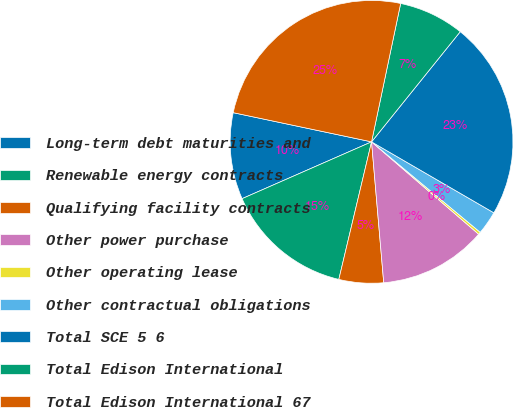Convert chart to OTSL. <chart><loc_0><loc_0><loc_500><loc_500><pie_chart><fcel>Long-term debt maturities and<fcel>Renewable energy contracts<fcel>Qualifying facility contracts<fcel>Other power purchase<fcel>Other operating lease<fcel>Other contractual obligations<fcel>Total SCE 5 6<fcel>Total Edison International<fcel>Total Edison International 67<nl><fcel>9.89%<fcel>14.7%<fcel>5.09%<fcel>12.3%<fcel>0.28%<fcel>2.68%<fcel>22.58%<fcel>7.49%<fcel>24.99%<nl></chart> 